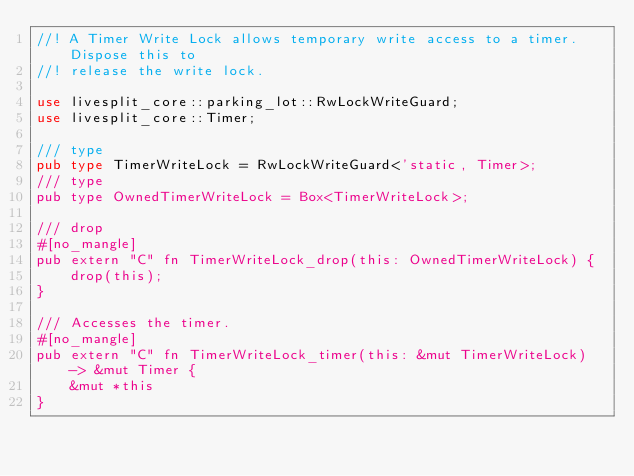Convert code to text. <code><loc_0><loc_0><loc_500><loc_500><_Rust_>//! A Timer Write Lock allows temporary write access to a timer. Dispose this to
//! release the write lock.

use livesplit_core::parking_lot::RwLockWriteGuard;
use livesplit_core::Timer;

/// type
pub type TimerWriteLock = RwLockWriteGuard<'static, Timer>;
/// type
pub type OwnedTimerWriteLock = Box<TimerWriteLock>;

/// drop
#[no_mangle]
pub extern "C" fn TimerWriteLock_drop(this: OwnedTimerWriteLock) {
    drop(this);
}

/// Accesses the timer.
#[no_mangle]
pub extern "C" fn TimerWriteLock_timer(this: &mut TimerWriteLock) -> &mut Timer {
    &mut *this
}
</code> 